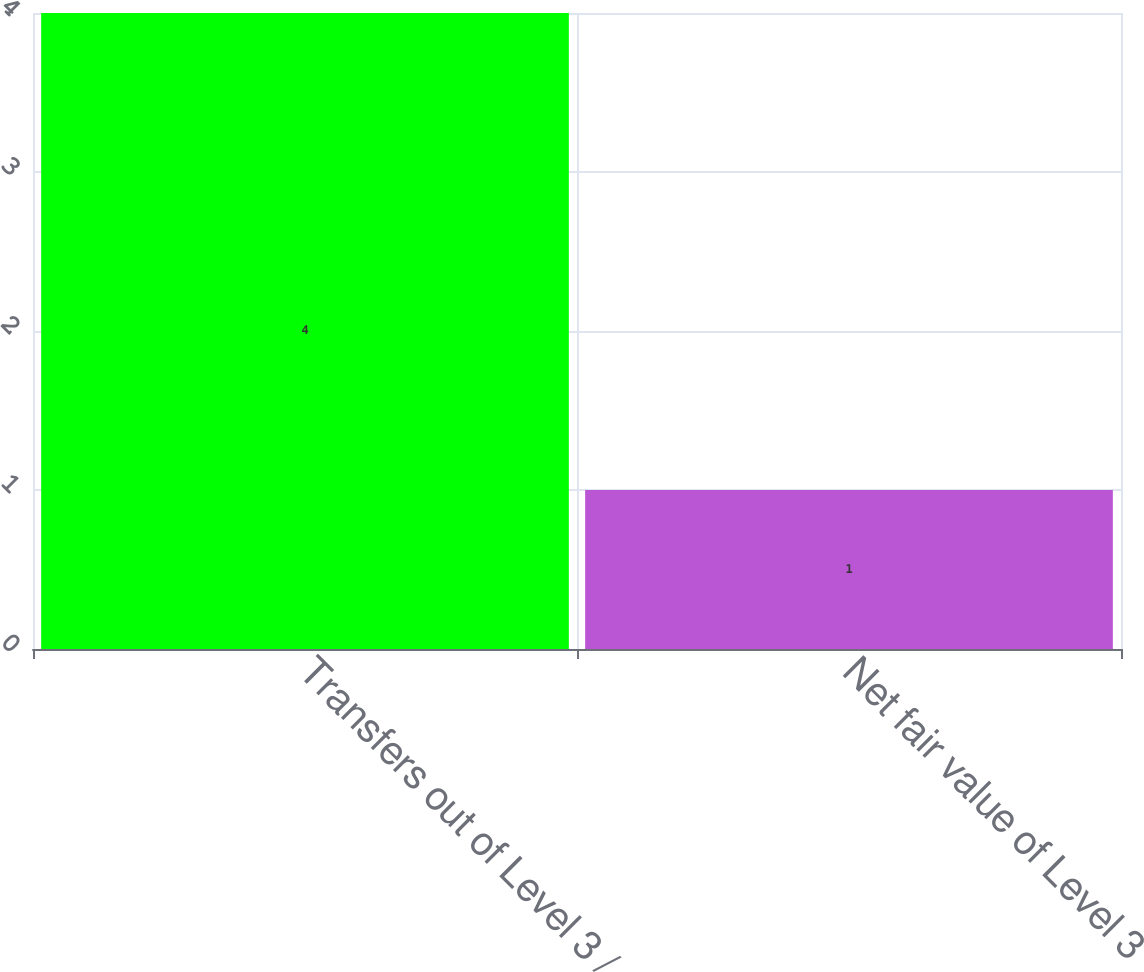<chart> <loc_0><loc_0><loc_500><loc_500><bar_chart><fcel>Transfers out of Level 3 /<fcel>Net fair value of Level 3<nl><fcel>4<fcel>1<nl></chart> 